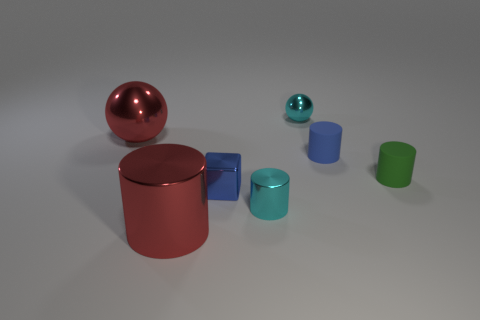Add 3 tiny yellow cubes. How many objects exist? 10 Subtract all cylinders. How many objects are left? 3 Add 4 cyan things. How many cyan things are left? 6 Add 7 brown rubber things. How many brown rubber things exist? 7 Subtract 0 red blocks. How many objects are left? 7 Subtract all cyan spheres. Subtract all tiny cyan cylinders. How many objects are left? 5 